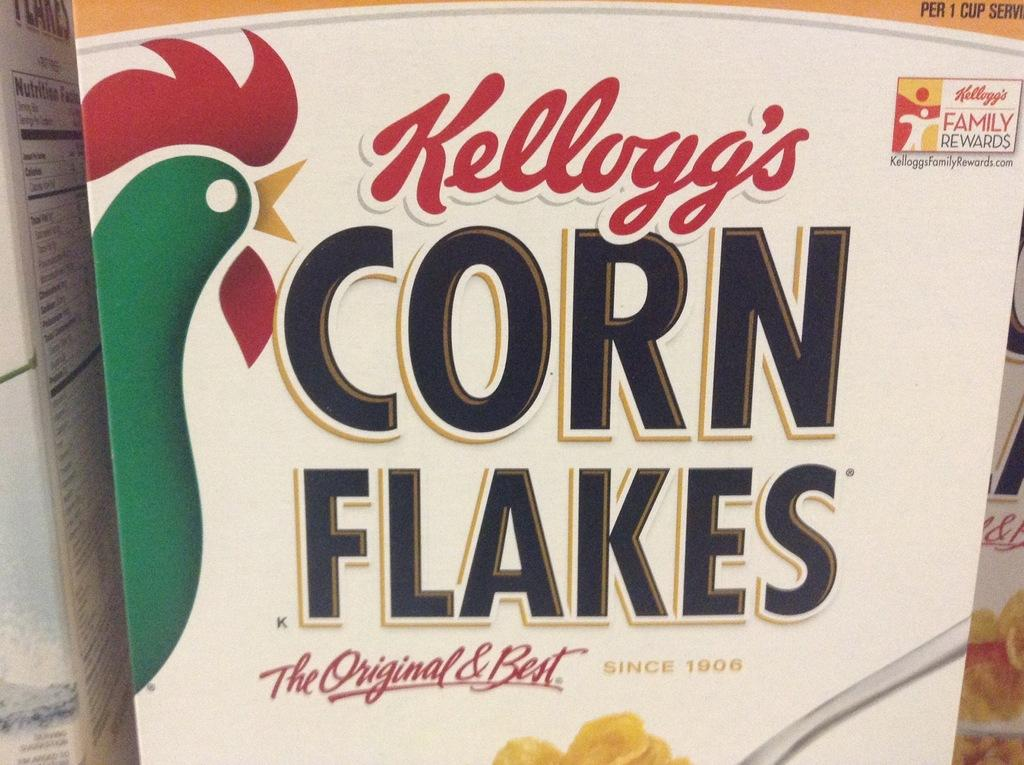What objects are present in the image? There are boxes in the image. Can you describe the appearance of the boxes? The boxes are colorful. Is there any specific brand or product mentioned on any of the boxes? Yes, one of the boxes has the name "Kellogg's corn flakes" written on it. What type of plough is being used to harvest the corn flakes in the image? There is no plough or corn flakes being harvested in the image; it features colorful boxes, one of which has the name "Kellogg's corn flakes" written on it. Can you tell me how many people are playing chess on the board in the image? There is no chess board or people playing chess in the image. 